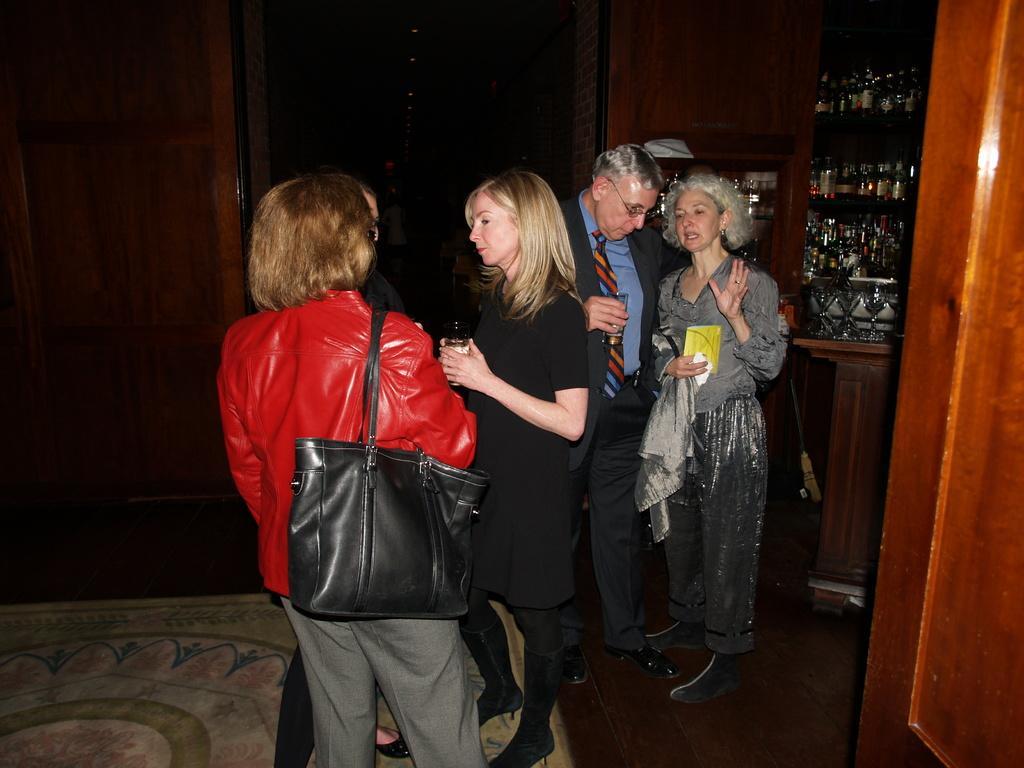Please provide a concise description of this image. There are few people standing and talking. This is the black color handbag holded by the women. these are the bottles which are kept inside the rack. I think these are the wine glasses. This looks like a door. This is the carpet on the floor. 